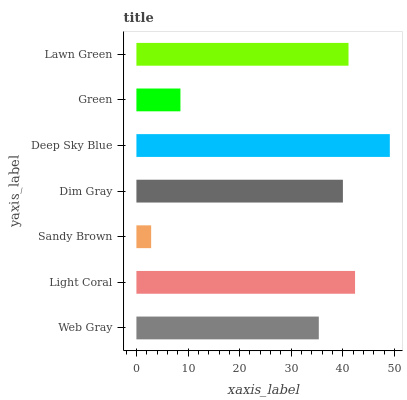Is Sandy Brown the minimum?
Answer yes or no. Yes. Is Deep Sky Blue the maximum?
Answer yes or no. Yes. Is Light Coral the minimum?
Answer yes or no. No. Is Light Coral the maximum?
Answer yes or no. No. Is Light Coral greater than Web Gray?
Answer yes or no. Yes. Is Web Gray less than Light Coral?
Answer yes or no. Yes. Is Web Gray greater than Light Coral?
Answer yes or no. No. Is Light Coral less than Web Gray?
Answer yes or no. No. Is Dim Gray the high median?
Answer yes or no. Yes. Is Dim Gray the low median?
Answer yes or no. Yes. Is Lawn Green the high median?
Answer yes or no. No. Is Lawn Green the low median?
Answer yes or no. No. 